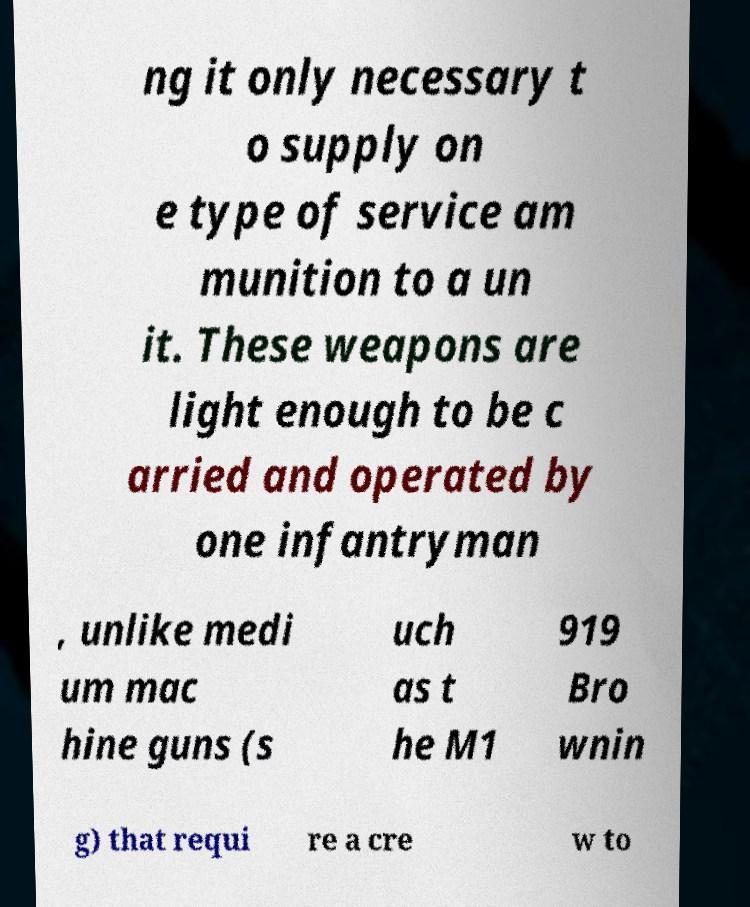I need the written content from this picture converted into text. Can you do that? ng it only necessary t o supply on e type of service am munition to a un it. These weapons are light enough to be c arried and operated by one infantryman , unlike medi um mac hine guns (s uch as t he M1 919 Bro wnin g) that requi re a cre w to 